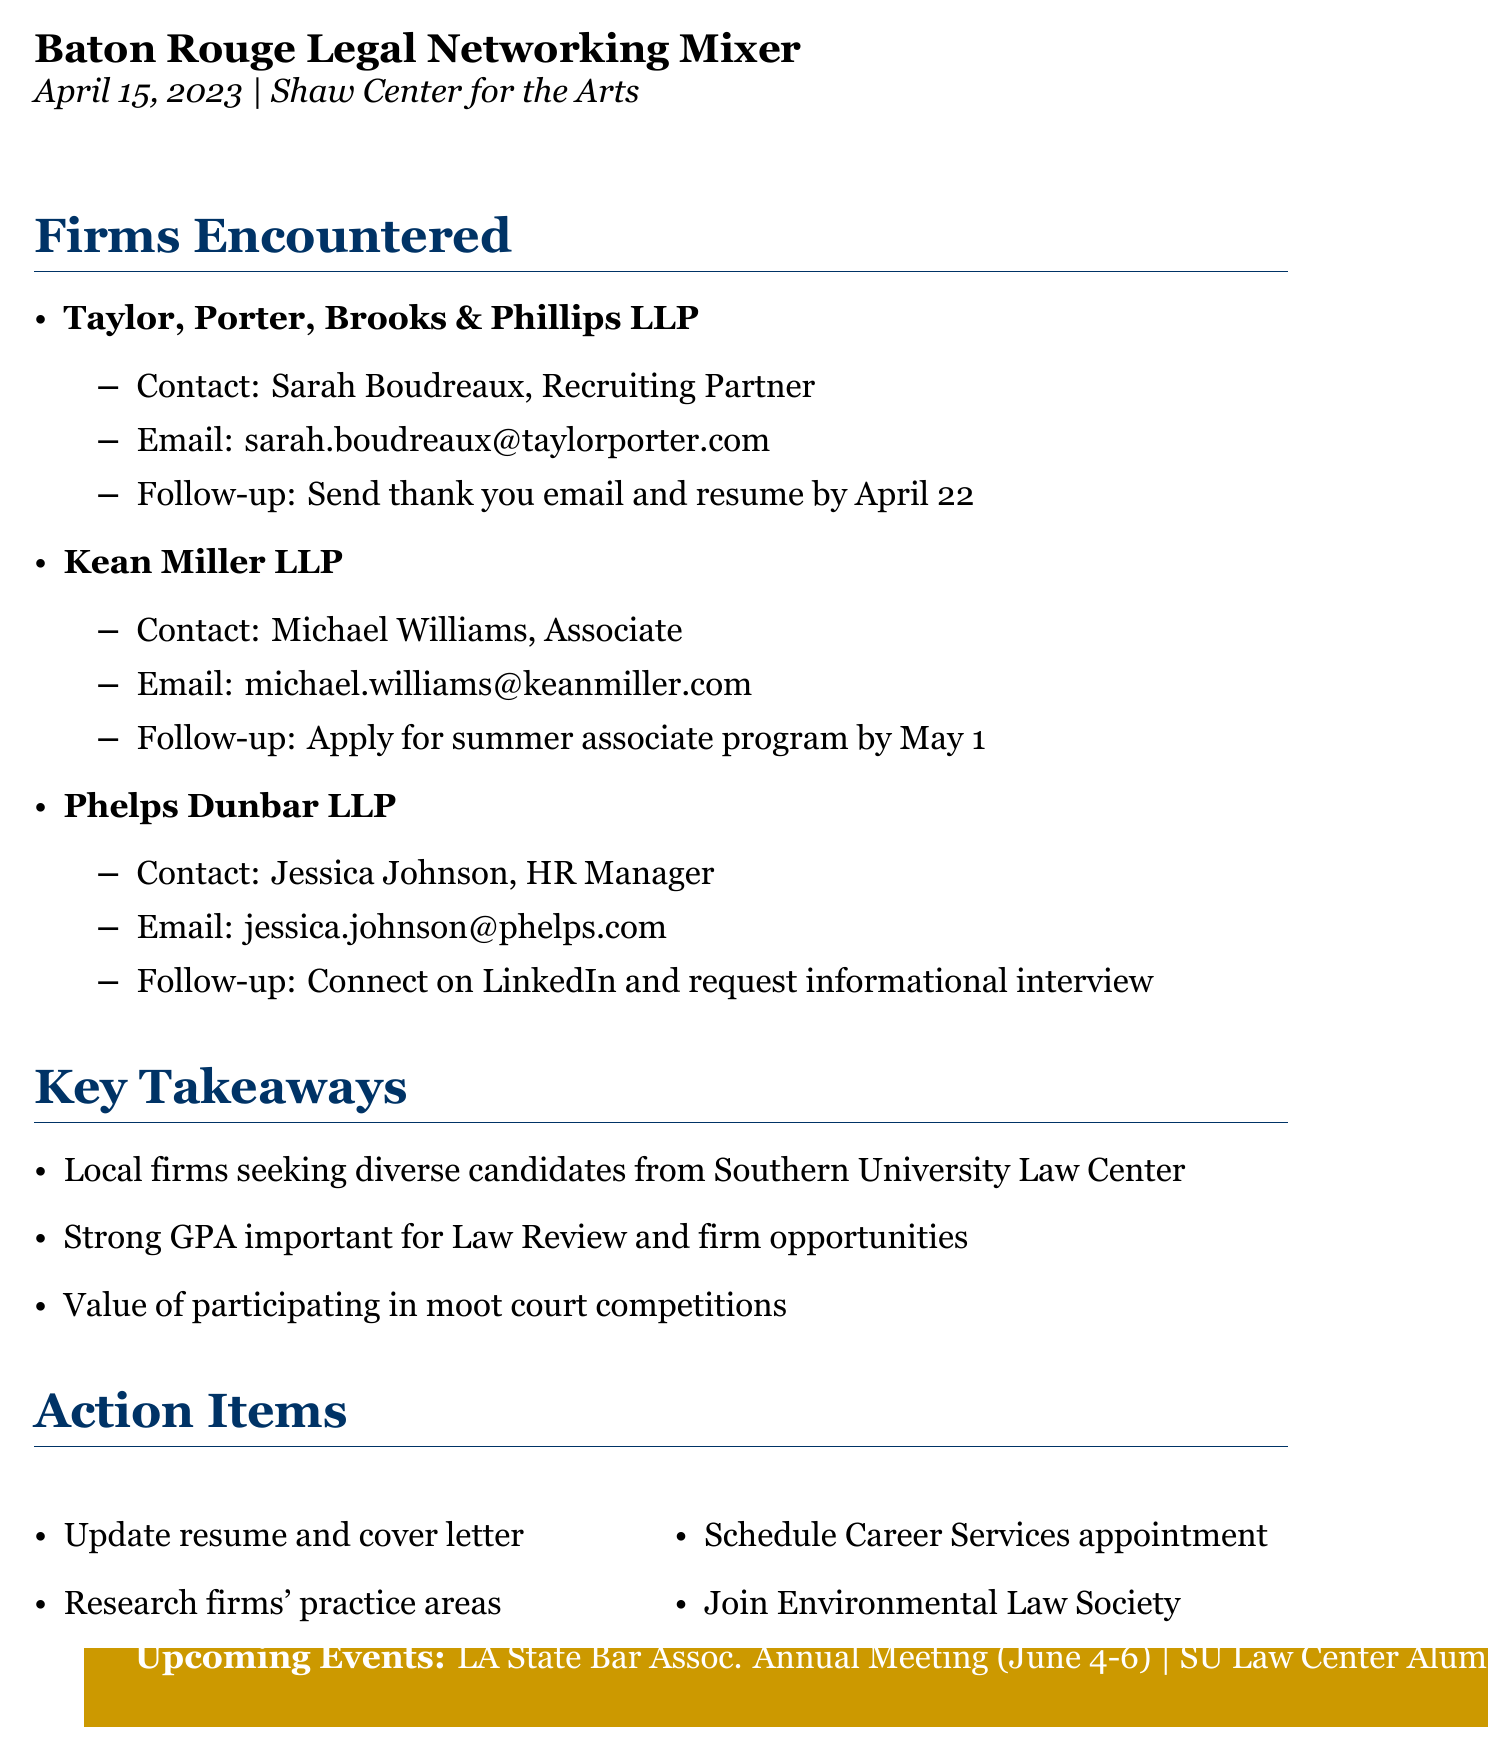what is the name of the networking event? The name of the networking event is stated at the beginning of the document.
Answer: Baton Rouge Legal Networking Mixer when did the networking event take place? The date of the event is provided in the document.
Answer: April 15, 2023 who is the contact person for Taylor, Porter, Brooks & Phillips LLP? The document specifies the contact for this firm under its details.
Answer: Sarah Boudreaux what is the follow-up action for Kean Miller LLP? The follow-up action for this firm is outlined in the firm's encounter section.
Answer: Apply for their summer associate program by May 1 what is one of the key takeaways from the event? The document lists key takeaways, which summarize important insights from the event.
Answer: Local firms are actively seeking diverse candidates from Southern University Law Center how many firms were encountered at the event? The document enumerates the firms encountered, indicating a specific count.
Answer: Three what action item involves the Environmental Law Society? Action items are listed in a designated section and this specifically connects with a firm's focus.
Answer: Join the Southern University Law Center's Environmental Law Society to align with Kean Miller's practice area when is the Southern University Law Center Alumni Mixer? The date for this upcoming event is mentioned in the events section of the document.
Answer: May 20, 2023 what is one suggested networking tip from the memo? Tips are included in the document to enhance networking skills.
Answer: Always bring business cards to networking events 